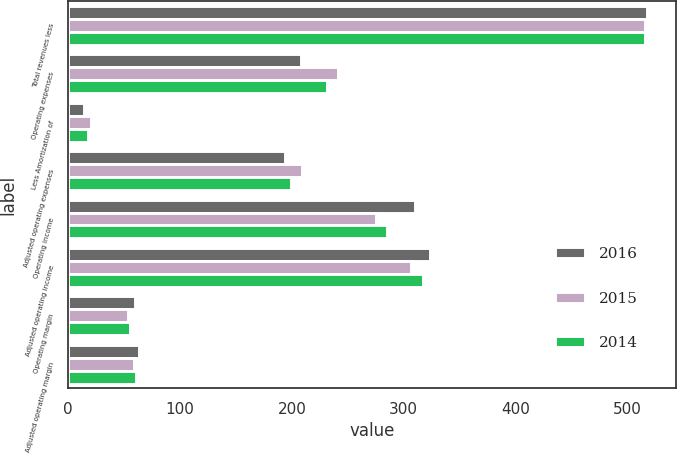Convert chart to OTSL. <chart><loc_0><loc_0><loc_500><loc_500><stacked_bar_chart><ecel><fcel>Total revenues less<fcel>Operating expenses<fcel>Less Amortization of<fcel>Adjusted operating expenses<fcel>Operating income<fcel>Adjusted operating income<fcel>Operating margin<fcel>Adjusted operating margin<nl><fcel>2016<fcel>518<fcel>208<fcel>14<fcel>194<fcel>310<fcel>324<fcel>60<fcel>63<nl><fcel>2015<fcel>516<fcel>241<fcel>20<fcel>209<fcel>275<fcel>307<fcel>53<fcel>59<nl><fcel>2014<fcel>516<fcel>231<fcel>18<fcel>199<fcel>285<fcel>317<fcel>55<fcel>61<nl></chart> 